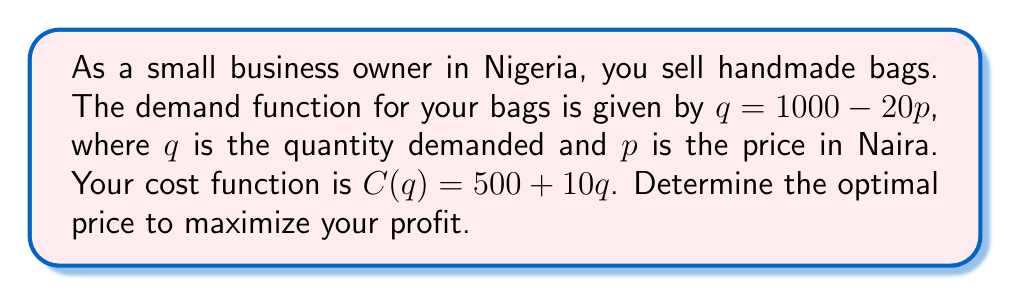Can you solve this math problem? Let's approach this step-by-step:

1) First, we need to express the profit function in terms of p:
   Revenue = $pq = p(1000 - 20p) = 1000p - 20p^2$
   Cost = $C(q) = 500 + 10q = 500 + 10(1000 - 20p) = 10000 - 200p + 500 = 10500 - 200p$
   Profit = Revenue - Cost
   $\Pi(p) = (1000p - 20p^2) - (10500 - 200p) = 1200p - 20p^2 - 10500$

2) To maximize profit, we need to find where the derivative of the profit function equals zero:
   $\frac{d\Pi}{dp} = 1200 - 40p$

3) Set this equal to zero and solve for p:
   $1200 - 40p = 0$
   $40p = 1200$
   $p = 30$

4) To confirm this is a maximum, we can check the second derivative:
   $\frac{d^2\Pi}{dp^2} = -40$
   Since this is negative, we confirm that $p = 30$ gives a maximum.

5) Therefore, the optimal price is 30 Naira.
Answer: 30 Naira 